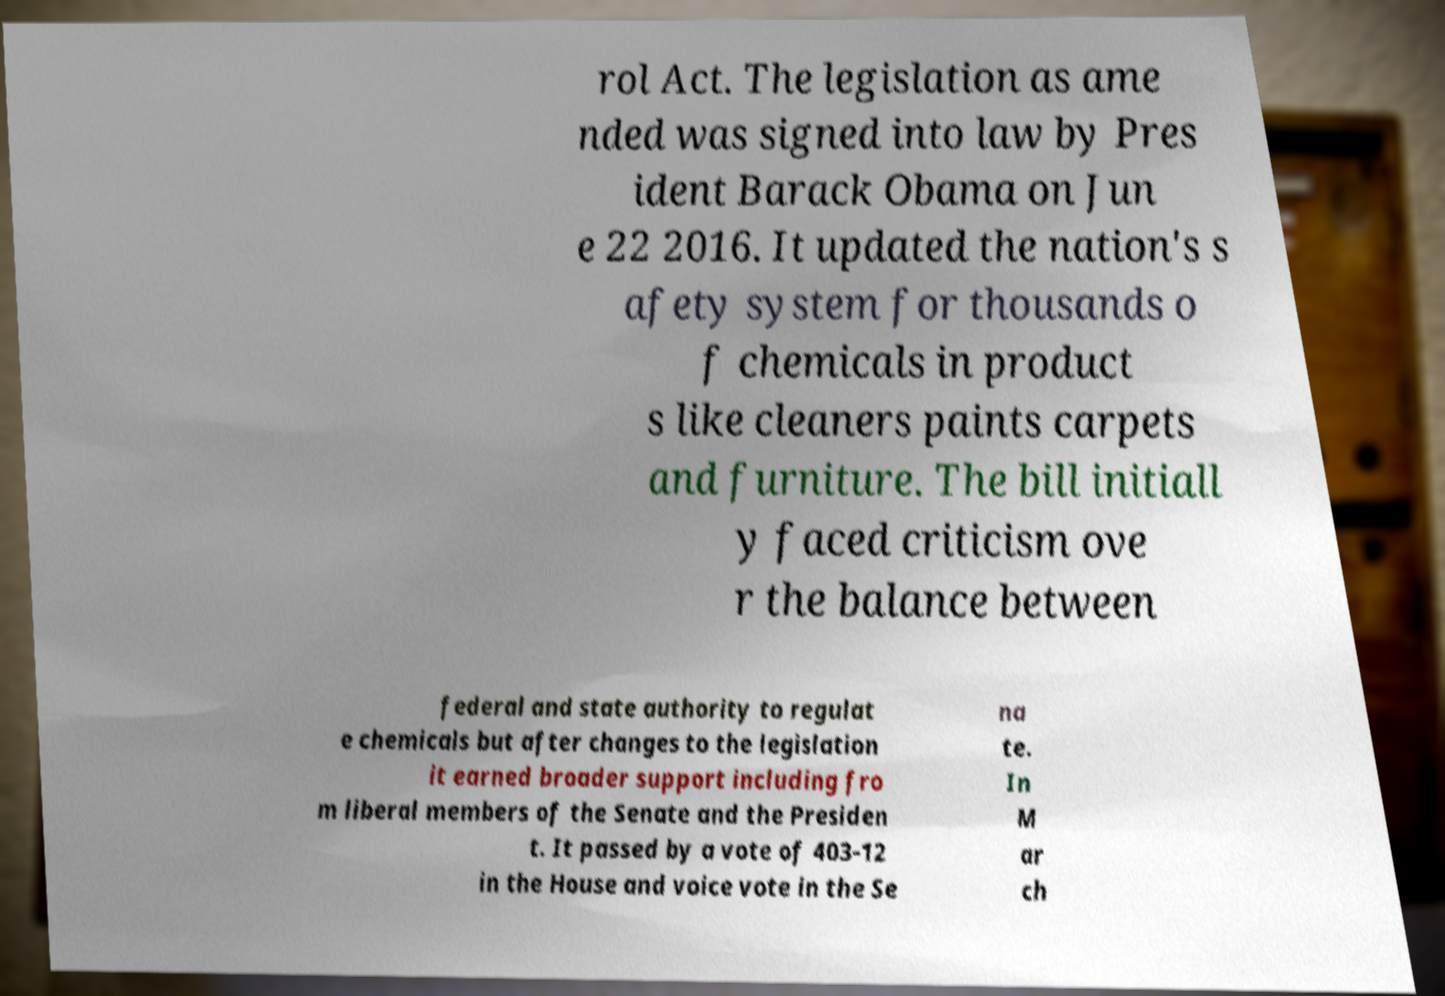For documentation purposes, I need the text within this image transcribed. Could you provide that? rol Act. The legislation as ame nded was signed into law by Pres ident Barack Obama on Jun e 22 2016. It updated the nation's s afety system for thousands o f chemicals in product s like cleaners paints carpets and furniture. The bill initiall y faced criticism ove r the balance between federal and state authority to regulat e chemicals but after changes to the legislation it earned broader support including fro m liberal members of the Senate and the Presiden t. It passed by a vote of 403-12 in the House and voice vote in the Se na te. In M ar ch 